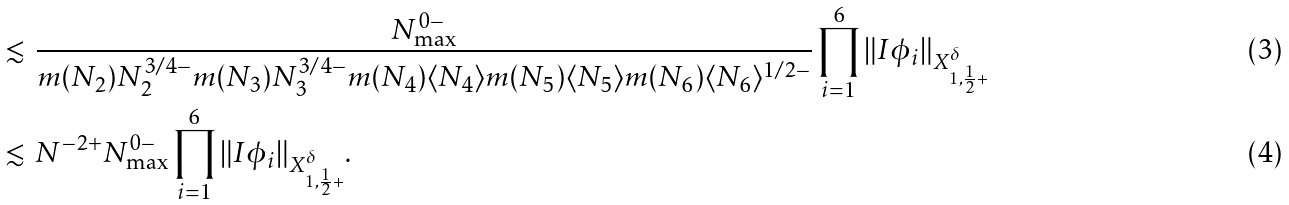<formula> <loc_0><loc_0><loc_500><loc_500>& \lesssim \, \frac { N _ { \max } ^ { 0 - } } { m ( N _ { 2 } ) N _ { 2 } ^ { 3 / 4 - } m ( N _ { 3 } ) N _ { 3 } ^ { 3 / 4 - } m ( N _ { 4 } ) \langle N _ { 4 } \rangle m ( N _ { 5 } ) \langle N _ { 5 } \rangle m ( N _ { 6 } ) \langle N _ { 6 } \rangle ^ { 1 / 2 - } } \prod _ { i = 1 } ^ { 6 } \| I \phi _ { i } \| _ { X ^ { \delta } _ { 1 , \frac { 1 } { 2 } + } } \\ & \lesssim \, N ^ { - 2 + } N _ { \max } ^ { 0 - } \prod _ { i = 1 } ^ { 6 } \| I \phi _ { i } \| _ { X ^ { \delta } _ { 1 , \frac { 1 } { 2 } + } } .</formula> 